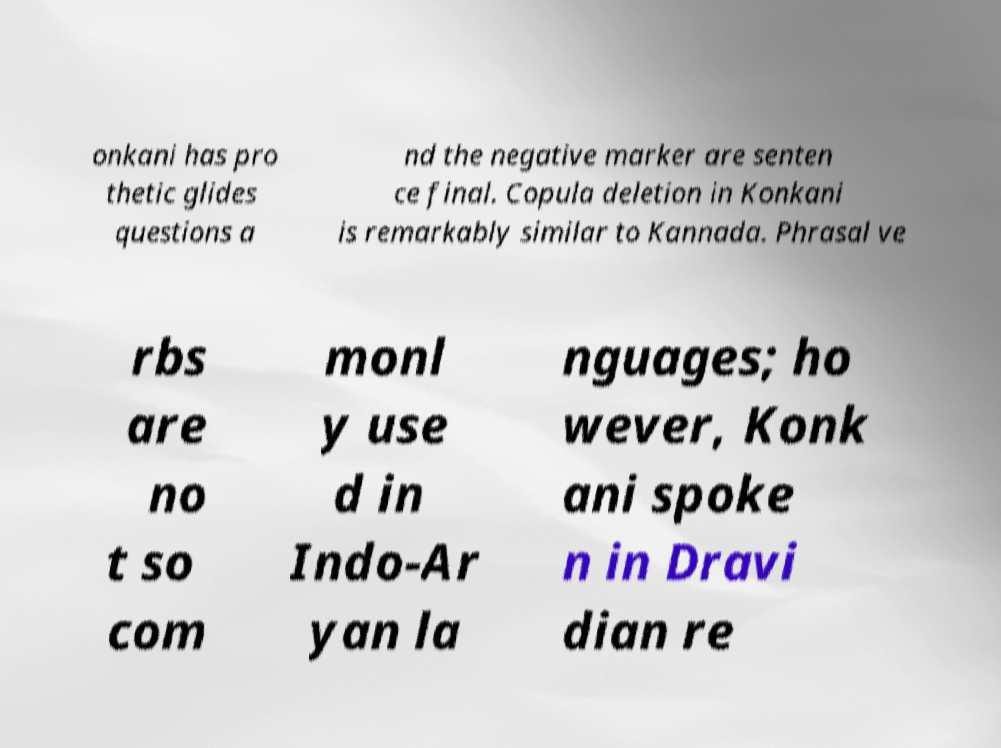Could you extract and type out the text from this image? onkani has pro thetic glides questions a nd the negative marker are senten ce final. Copula deletion in Konkani is remarkably similar to Kannada. Phrasal ve rbs are no t so com monl y use d in Indo-Ar yan la nguages; ho wever, Konk ani spoke n in Dravi dian re 